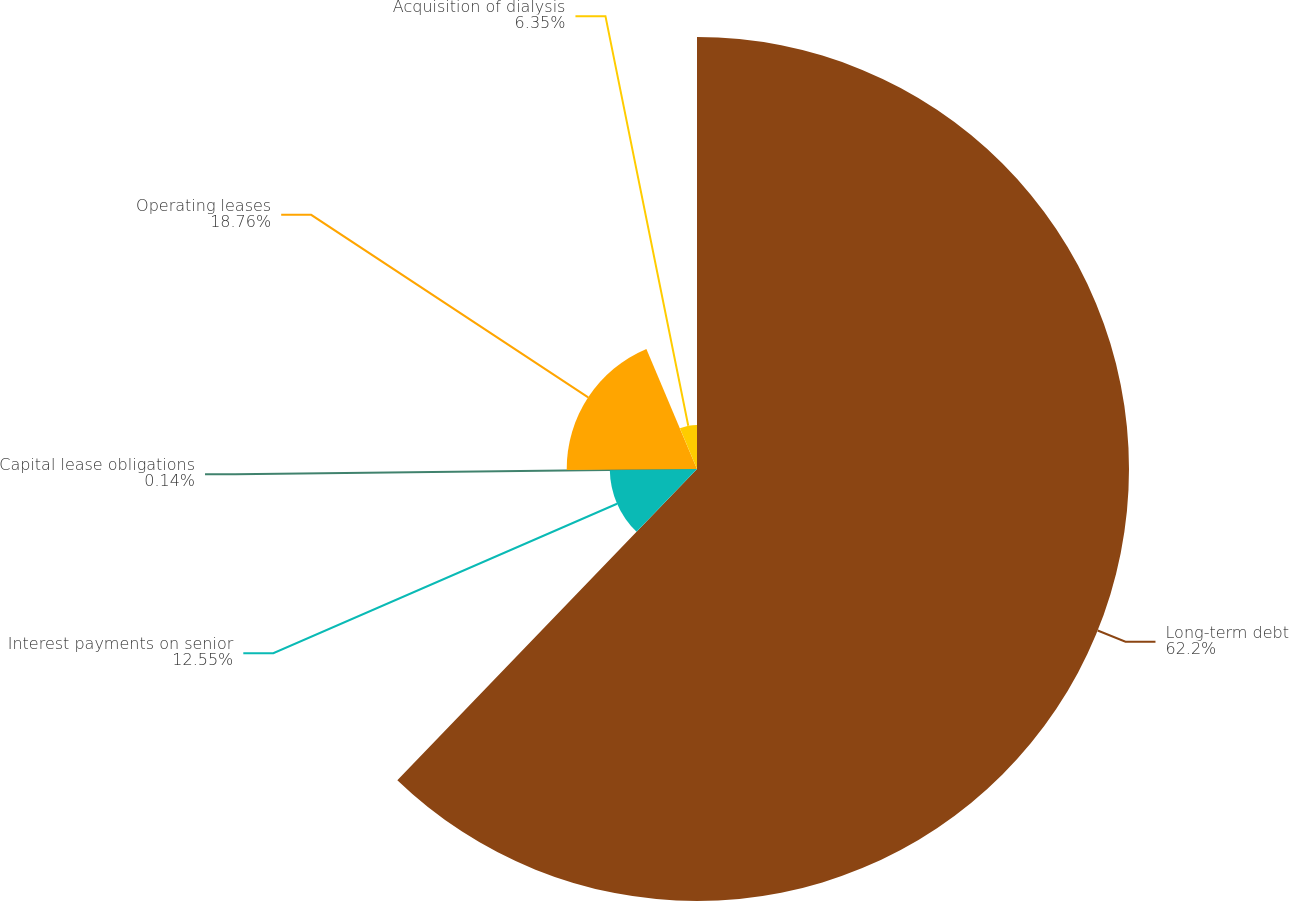<chart> <loc_0><loc_0><loc_500><loc_500><pie_chart><fcel>Long-term debt<fcel>Interest payments on senior<fcel>Capital lease obligations<fcel>Operating leases<fcel>Acquisition of dialysis<nl><fcel>62.2%<fcel>12.55%<fcel>0.14%<fcel>18.76%<fcel>6.35%<nl></chart> 